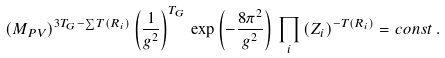<formula> <loc_0><loc_0><loc_500><loc_500>( M _ { P V } ) ^ { 3 T _ { G } - \sum T ( R _ { i } ) } \left ( \frac { 1 } { g ^ { 2 } } \right ) ^ { T _ { G } } \, \exp \left ( - \frac { 8 \pi ^ { 2 } } { g ^ { 2 } } \right ) \, \prod _ { i } \left ( Z _ { i } \right ) ^ { - T ( R _ { i } ) } = c o n s t \, .</formula> 